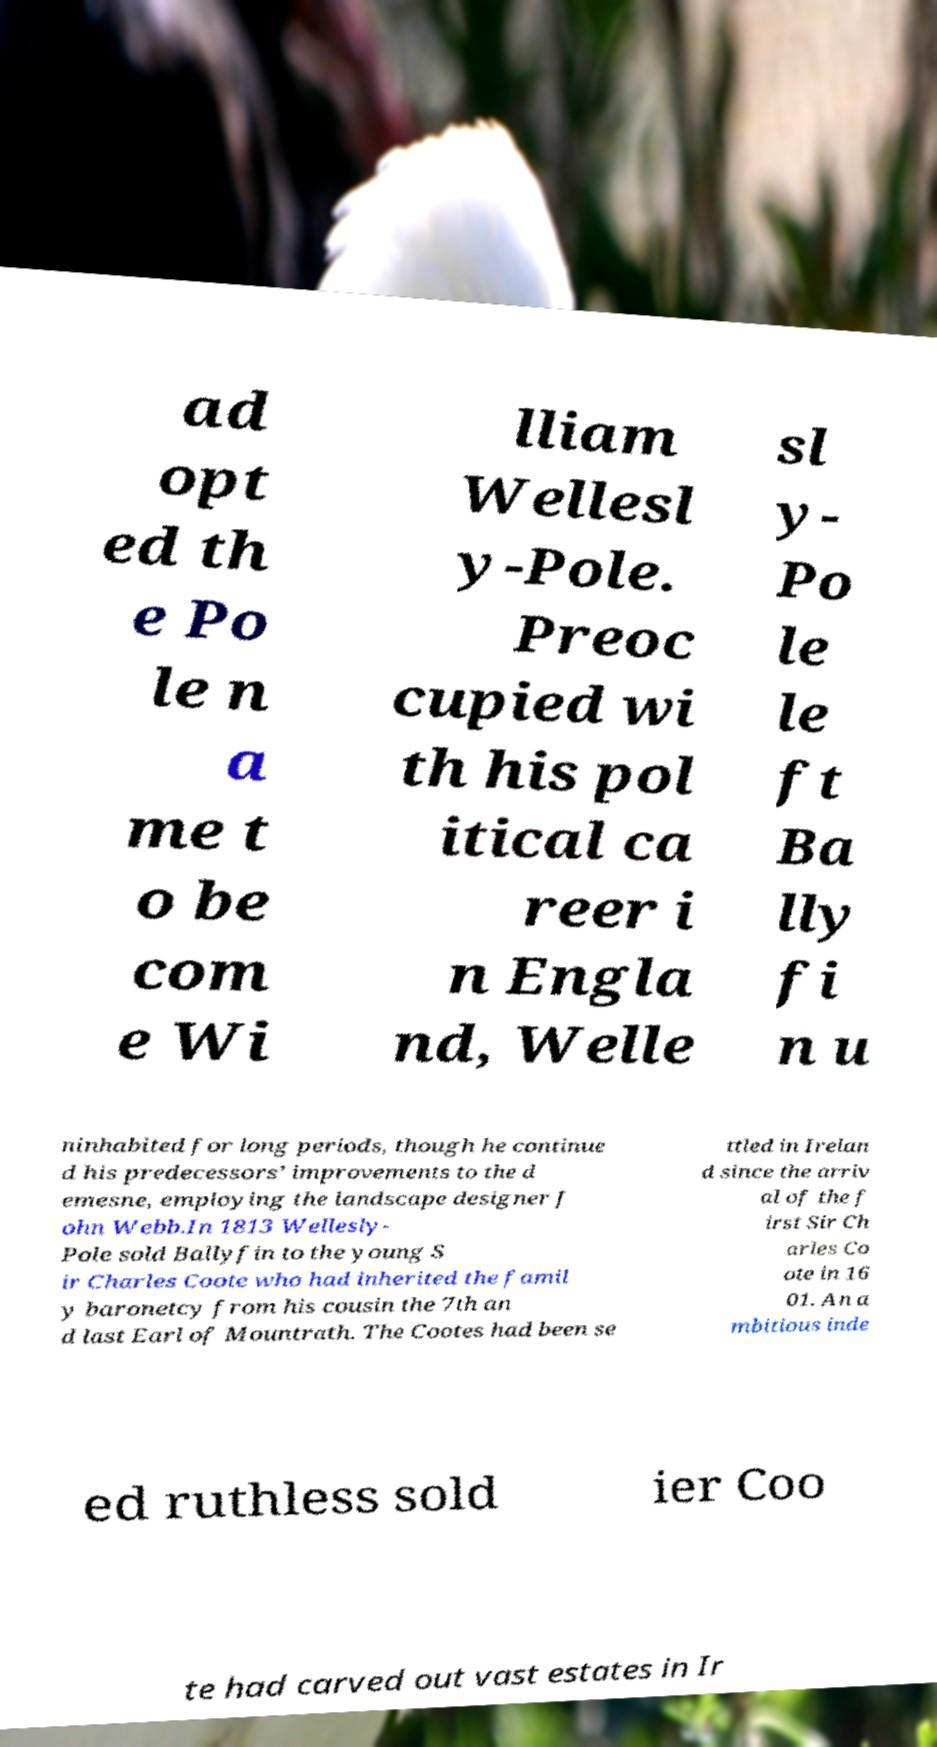What messages or text are displayed in this image? I need them in a readable, typed format. ad opt ed th e Po le n a me t o be com e Wi lliam Wellesl y-Pole. Preoc cupied wi th his pol itical ca reer i n Engla nd, Welle sl y- Po le le ft Ba lly fi n u ninhabited for long periods, though he continue d his predecessors’ improvements to the d emesne, employing the landscape designer J ohn Webb.In 1813 Wellesly- Pole sold Ballyfin to the young S ir Charles Coote who had inherited the famil y baronetcy from his cousin the 7th an d last Earl of Mountrath. The Cootes had been se ttled in Irelan d since the arriv al of the f irst Sir Ch arles Co ote in 16 01. An a mbitious inde ed ruthless sold ier Coo te had carved out vast estates in Ir 